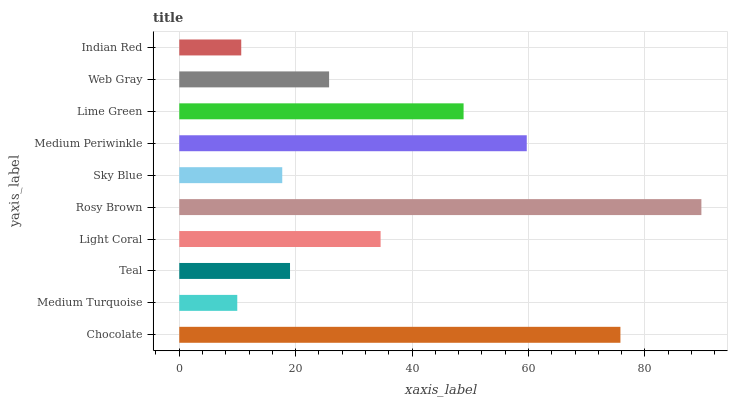Is Medium Turquoise the minimum?
Answer yes or no. Yes. Is Rosy Brown the maximum?
Answer yes or no. Yes. Is Teal the minimum?
Answer yes or no. No. Is Teal the maximum?
Answer yes or no. No. Is Teal greater than Medium Turquoise?
Answer yes or no. Yes. Is Medium Turquoise less than Teal?
Answer yes or no. Yes. Is Medium Turquoise greater than Teal?
Answer yes or no. No. Is Teal less than Medium Turquoise?
Answer yes or no. No. Is Light Coral the high median?
Answer yes or no. Yes. Is Web Gray the low median?
Answer yes or no. Yes. Is Medium Turquoise the high median?
Answer yes or no. No. Is Teal the low median?
Answer yes or no. No. 